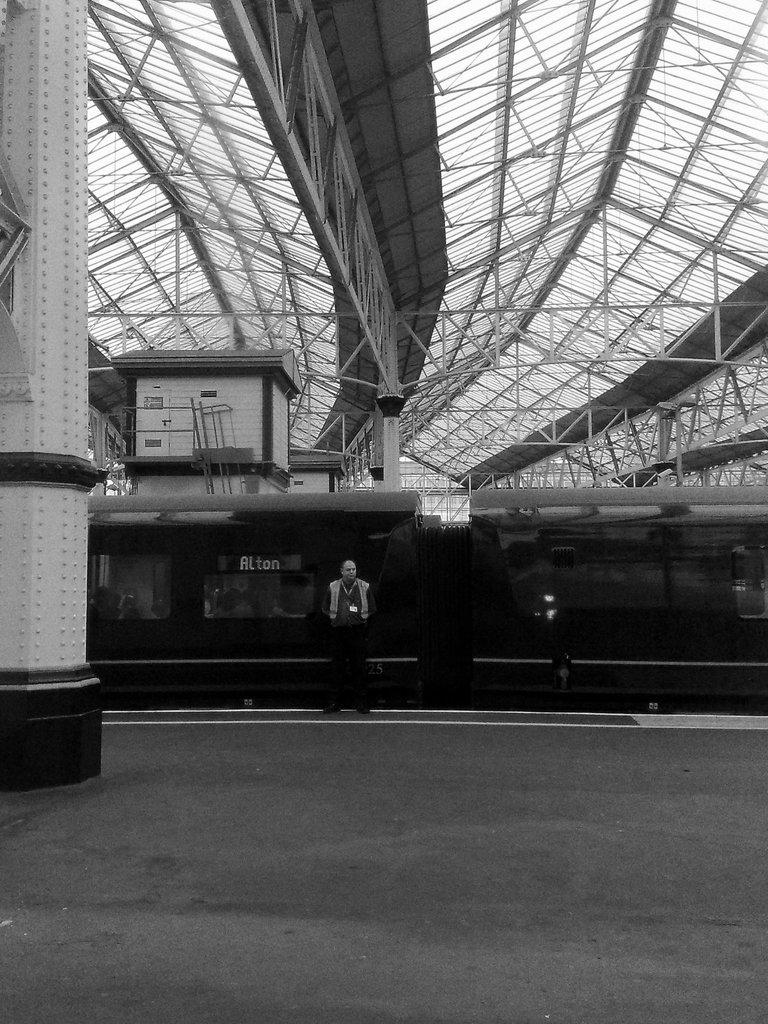What is the main subject of the image? There is a train in the image. What other objects can be seen in the image? There is a pillar and a person standing beside the train. What part of the train station is visible in the image? The rooftop is visible in the image. How is the image presented? The image is in black and white mode. What type of wax can be seen melting on the duck's back in the image? There is no wax or duck present in the image. 